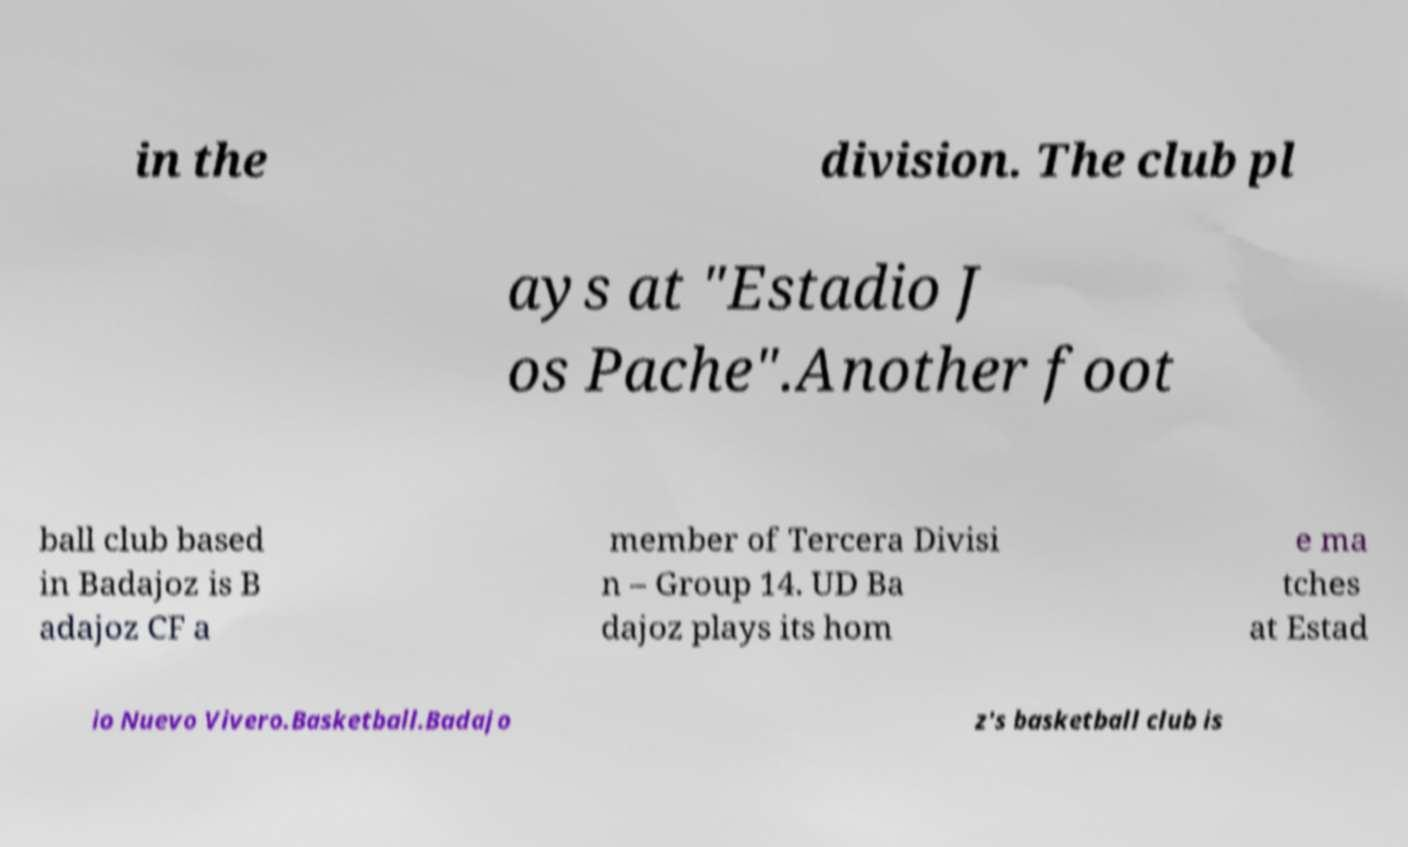For documentation purposes, I need the text within this image transcribed. Could you provide that? in the division. The club pl ays at "Estadio J os Pache".Another foot ball club based in Badajoz is B adajoz CF a member of Tercera Divisi n – Group 14. UD Ba dajoz plays its hom e ma tches at Estad io Nuevo Vivero.Basketball.Badajo z's basketball club is 